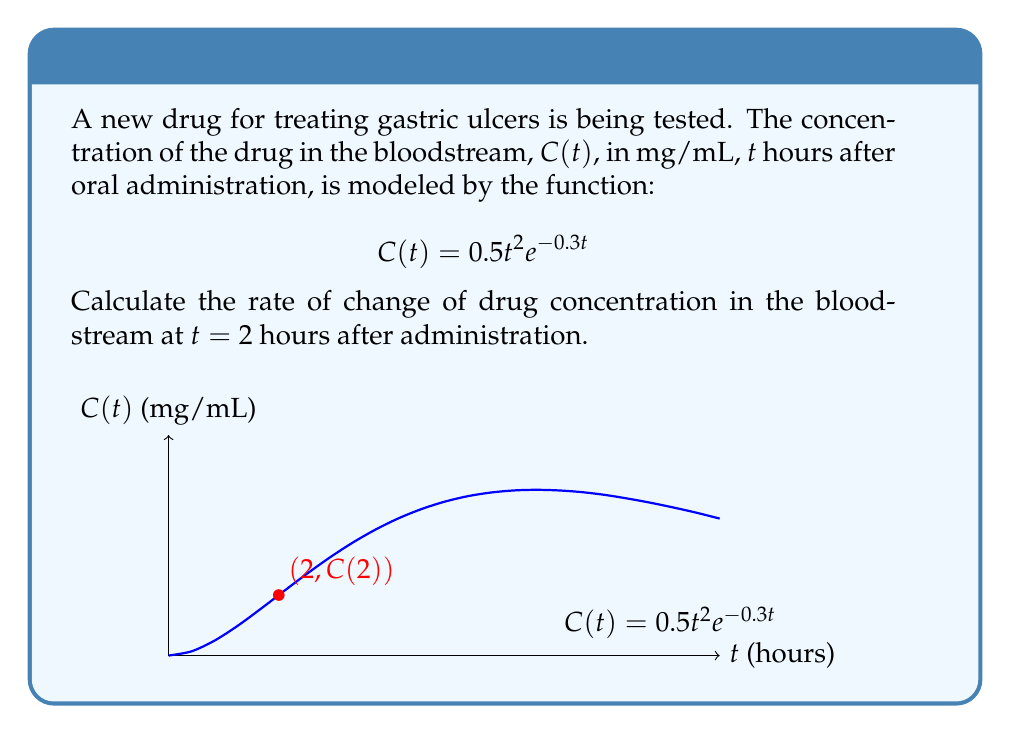Teach me how to tackle this problem. To find the rate of change of drug concentration at $t = 2$ hours, we need to calculate the derivative of $C(t)$ and evaluate it at $t = 2$.

Step 1: Find $C'(t)$ using the product rule and chain rule.
$$C(t) = 0.5t^2e^{-0.3t}$$
$$C'(t) = 0.5 \cdot 2t \cdot e^{-0.3t} + 0.5t^2 \cdot (-0.3)e^{-0.3t}$$
$$C'(t) = te^{-0.3t} - 0.15t^2e^{-0.3t}$$
$$C'(t) = e^{-0.3t}(t - 0.15t^2)$$

Step 2: Evaluate $C'(t)$ at $t = 2$.
$$C'(2) = e^{-0.3(2)}(2 - 0.15(2^2))$$
$$C'(2) = e^{-0.6}(2 - 0.6)$$
$$C'(2) = e^{-0.6} \cdot 1.4$$
$$C'(2) \approx 0.7679$$

The rate of change of drug concentration at $t = 2$ hours is approximately 0.7679 mg/mL per hour.
Answer: $0.7679$ mg/mL/hr 